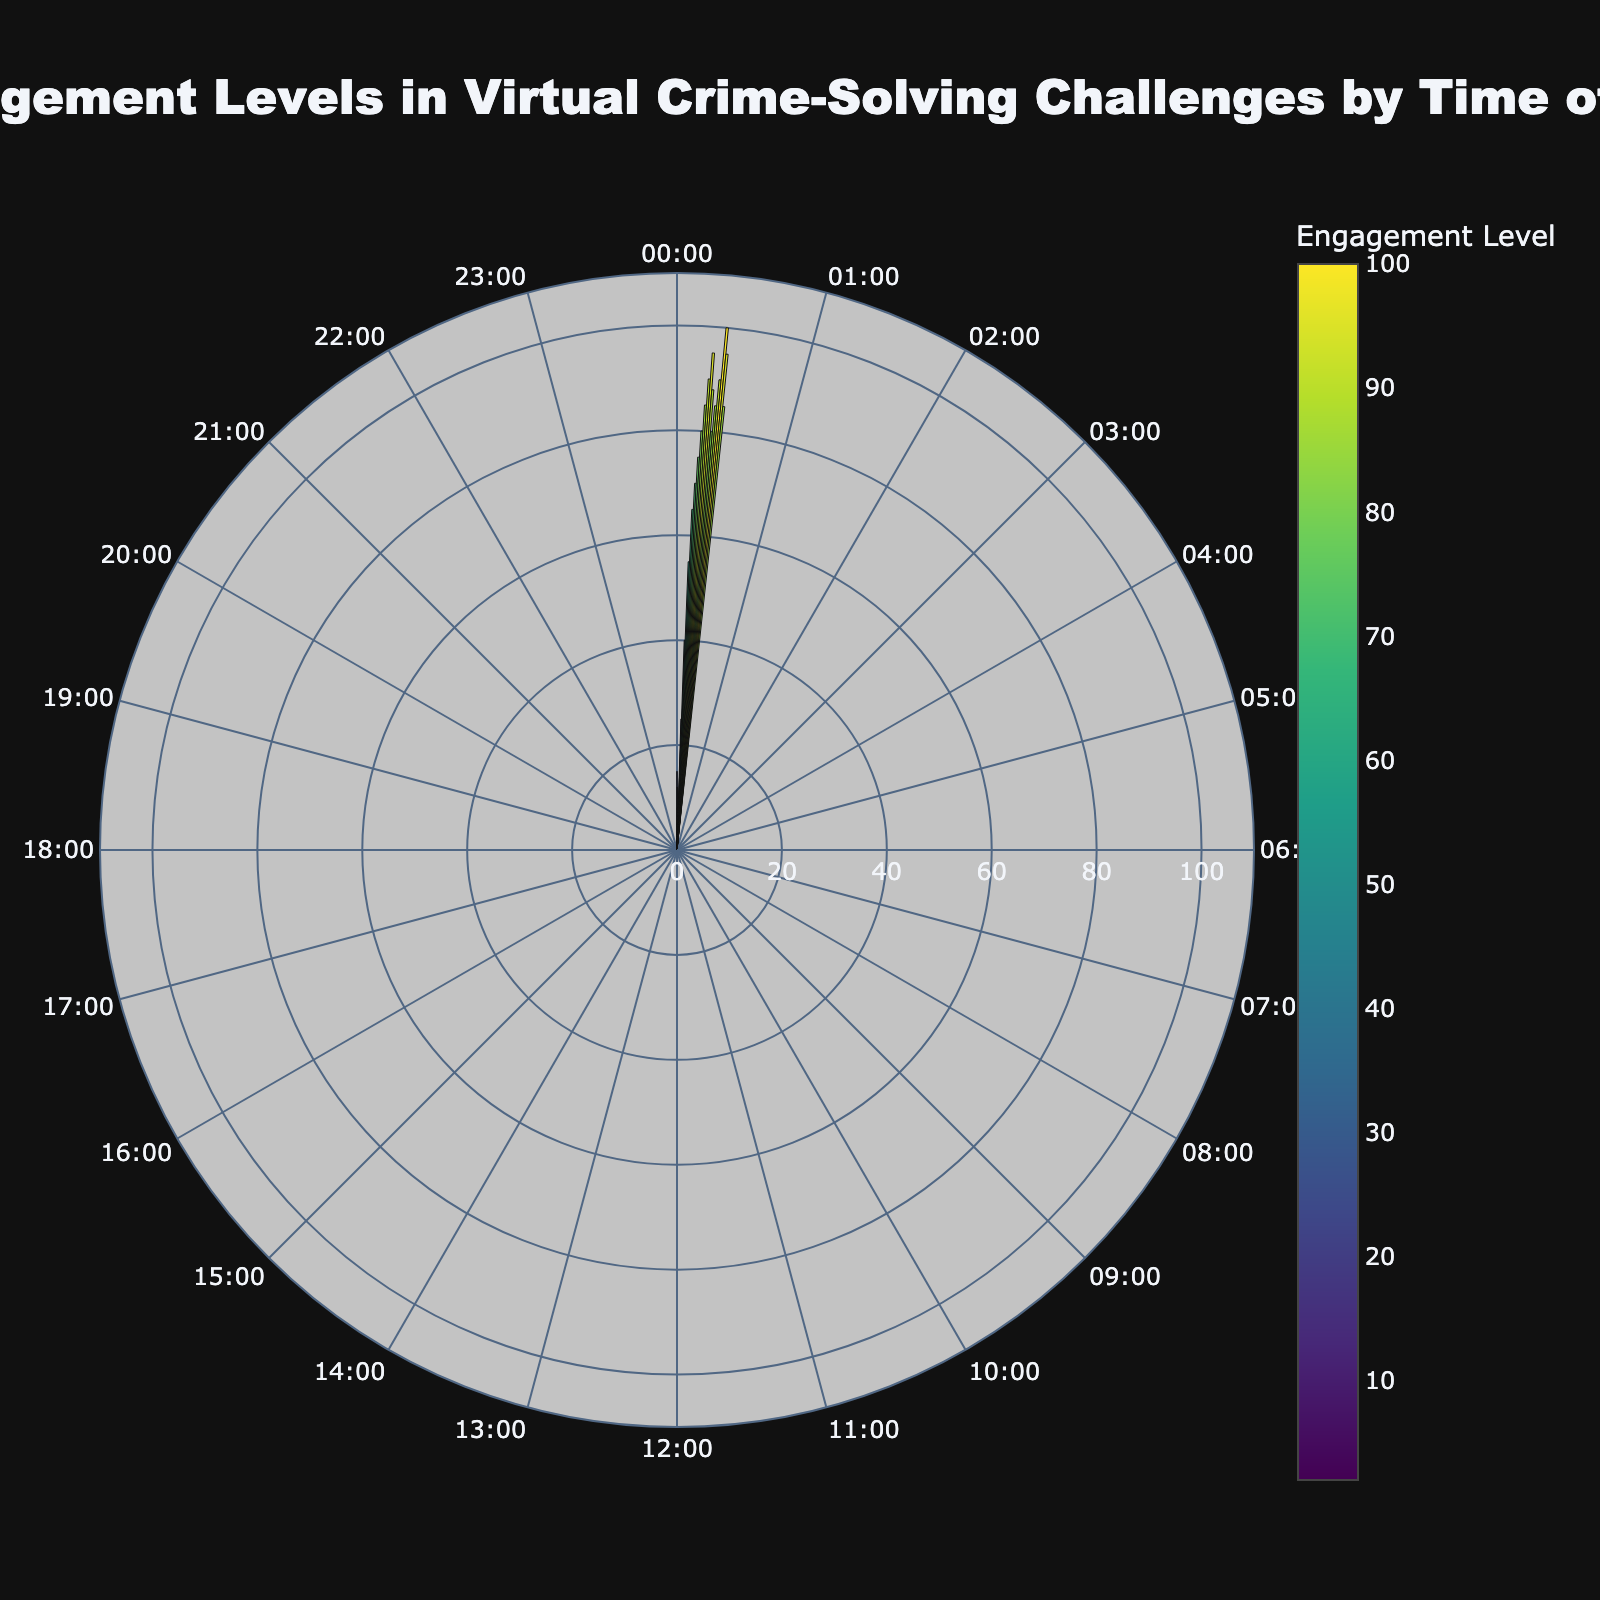What is the title of the chart? The title is written at the top of the chart, centered and bold, thus it reads: Engagement Levels in Virtual Crime-Solving Challenges by Time of Day.
Answer: Engagement Levels in Virtual Crime-Solving Challenges by Time of Day At what time is the engagement level the highest? Observing the radial bars, the longest one corresponds to the time 21:00. Therefore, the highest engagement level is at 21:00.
Answer: 21:00 How many hourly time points are displayed on the chart? The chart shows a radial bar for every hour of the day, adding up to 24 time points. All are equally spaced around the polar plot.
Answer: 24 What is the engagement level at 11:00? By locating 11:00 on the angular axis and checking the corresponding radial bar, the length indicates an engagement level of 70.
Answer: 70 What is the difference in engagement levels between 10:00 and 22:00? To find the difference, check the lengths of bars at 10:00 and 22:00 which are 65 and 95, respectively, then subtract: 95 - 65 = 30.
Answer: 30 Which two consecutive hours show the largest increase in engagement level? Comparing the radial bar lengths for all consecutive hours, the largest increase is between 7:00 (25) and 8:00 (40) with an increase of 30.
Answer: 7:00 and 8:00 What is the average engagement level between 20:00 and 23:00? The engagement levels between 20:00 and 23:00 are: 90, 100, 95, 85. Summing them: 90 + 100 + 95 + 85 = 370. Dividing by 4 (the number of hours): 370 / 4 = 92.5.
Answer: 92.5 Which time period shows the lowest engagement? Reviewing the 3:00 to 5:00 hours, the lowest engagement level is at 5:00 with an engagement level of 2.
Answer: 5:00 Is the engagement level more stable in the morning (0:00-11:00) or the evening (12:00-23:00)? The morning hours show more variability with values ranging from 2 to 75. The evening period's engagement levels are relatively high and consistent, 75 to 100 generally. Thus, the evening is more stable.
Answer: Evening 